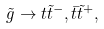<formula> <loc_0><loc_0><loc_500><loc_500>\tilde { g } \rightarrow t \tilde { t } ^ { - } , \bar { t } \tilde { t } ^ { + } ,</formula> 